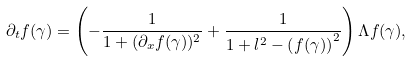<formula> <loc_0><loc_0><loc_500><loc_500>\partial _ { t } f ( \gamma ) = \left ( - \frac { 1 } { 1 + ( \partial _ { x } f ( \gamma ) ) ^ { 2 } } + \frac { 1 } { 1 + l ^ { 2 } - \left ( f ( \gamma ) \right ) ^ { 2 } } \right ) \Lambda f ( \gamma ) ,</formula> 